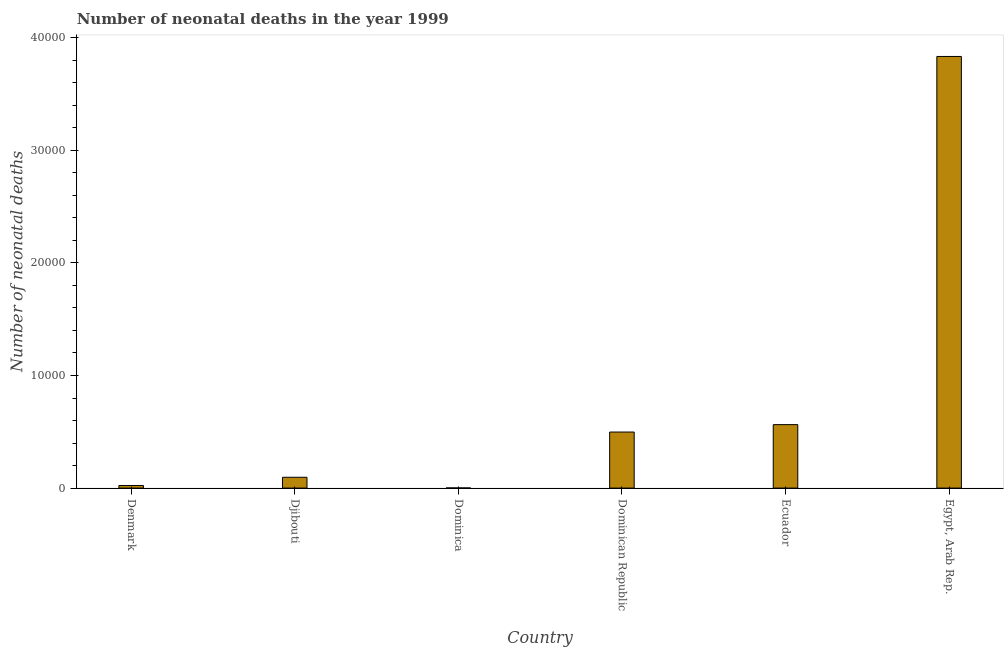Does the graph contain any zero values?
Your answer should be compact. No. What is the title of the graph?
Ensure brevity in your answer.  Number of neonatal deaths in the year 1999. What is the label or title of the Y-axis?
Offer a terse response. Number of neonatal deaths. What is the number of neonatal deaths in Ecuador?
Your response must be concise. 5636. Across all countries, what is the maximum number of neonatal deaths?
Offer a terse response. 3.83e+04. Across all countries, what is the minimum number of neonatal deaths?
Offer a very short reply. 13. In which country was the number of neonatal deaths maximum?
Keep it short and to the point. Egypt, Arab Rep. In which country was the number of neonatal deaths minimum?
Keep it short and to the point. Dominica. What is the sum of the number of neonatal deaths?
Provide a short and direct response. 5.02e+04. What is the difference between the number of neonatal deaths in Denmark and Dominica?
Give a very brief answer. 218. What is the average number of neonatal deaths per country?
Offer a very short reply. 8359. What is the median number of neonatal deaths?
Your answer should be very brief. 2969.5. In how many countries, is the number of neonatal deaths greater than 22000 ?
Your answer should be compact. 1. What is the ratio of the number of neonatal deaths in Dominica to that in Dominican Republic?
Ensure brevity in your answer.  0. Is the number of neonatal deaths in Dominican Republic less than that in Ecuador?
Offer a very short reply. Yes. What is the difference between the highest and the second highest number of neonatal deaths?
Make the answer very short. 3.27e+04. What is the difference between the highest and the lowest number of neonatal deaths?
Offer a terse response. 3.83e+04. How many bars are there?
Provide a succinct answer. 6. How many countries are there in the graph?
Offer a very short reply. 6. What is the difference between two consecutive major ticks on the Y-axis?
Offer a very short reply. 10000. What is the Number of neonatal deaths in Denmark?
Keep it short and to the point. 231. What is the Number of neonatal deaths of Djibouti?
Keep it short and to the point. 961. What is the Number of neonatal deaths of Dominican Republic?
Ensure brevity in your answer.  4978. What is the Number of neonatal deaths in Ecuador?
Your response must be concise. 5636. What is the Number of neonatal deaths in Egypt, Arab Rep.?
Your answer should be compact. 3.83e+04. What is the difference between the Number of neonatal deaths in Denmark and Djibouti?
Keep it short and to the point. -730. What is the difference between the Number of neonatal deaths in Denmark and Dominica?
Offer a very short reply. 218. What is the difference between the Number of neonatal deaths in Denmark and Dominican Republic?
Provide a succinct answer. -4747. What is the difference between the Number of neonatal deaths in Denmark and Ecuador?
Your answer should be very brief. -5405. What is the difference between the Number of neonatal deaths in Denmark and Egypt, Arab Rep.?
Your answer should be very brief. -3.81e+04. What is the difference between the Number of neonatal deaths in Djibouti and Dominica?
Your response must be concise. 948. What is the difference between the Number of neonatal deaths in Djibouti and Dominican Republic?
Give a very brief answer. -4017. What is the difference between the Number of neonatal deaths in Djibouti and Ecuador?
Your answer should be compact. -4675. What is the difference between the Number of neonatal deaths in Djibouti and Egypt, Arab Rep.?
Make the answer very short. -3.74e+04. What is the difference between the Number of neonatal deaths in Dominica and Dominican Republic?
Offer a very short reply. -4965. What is the difference between the Number of neonatal deaths in Dominica and Ecuador?
Offer a terse response. -5623. What is the difference between the Number of neonatal deaths in Dominica and Egypt, Arab Rep.?
Make the answer very short. -3.83e+04. What is the difference between the Number of neonatal deaths in Dominican Republic and Ecuador?
Give a very brief answer. -658. What is the difference between the Number of neonatal deaths in Dominican Republic and Egypt, Arab Rep.?
Make the answer very short. -3.34e+04. What is the difference between the Number of neonatal deaths in Ecuador and Egypt, Arab Rep.?
Offer a terse response. -3.27e+04. What is the ratio of the Number of neonatal deaths in Denmark to that in Djibouti?
Your answer should be compact. 0.24. What is the ratio of the Number of neonatal deaths in Denmark to that in Dominica?
Offer a terse response. 17.77. What is the ratio of the Number of neonatal deaths in Denmark to that in Dominican Republic?
Make the answer very short. 0.05. What is the ratio of the Number of neonatal deaths in Denmark to that in Ecuador?
Your response must be concise. 0.04. What is the ratio of the Number of neonatal deaths in Denmark to that in Egypt, Arab Rep.?
Make the answer very short. 0.01. What is the ratio of the Number of neonatal deaths in Djibouti to that in Dominica?
Your answer should be compact. 73.92. What is the ratio of the Number of neonatal deaths in Djibouti to that in Dominican Republic?
Your answer should be compact. 0.19. What is the ratio of the Number of neonatal deaths in Djibouti to that in Ecuador?
Offer a very short reply. 0.17. What is the ratio of the Number of neonatal deaths in Djibouti to that in Egypt, Arab Rep.?
Ensure brevity in your answer.  0.03. What is the ratio of the Number of neonatal deaths in Dominica to that in Dominican Republic?
Your response must be concise. 0. What is the ratio of the Number of neonatal deaths in Dominica to that in Ecuador?
Your answer should be very brief. 0. What is the ratio of the Number of neonatal deaths in Dominican Republic to that in Ecuador?
Make the answer very short. 0.88. What is the ratio of the Number of neonatal deaths in Dominican Republic to that in Egypt, Arab Rep.?
Provide a short and direct response. 0.13. What is the ratio of the Number of neonatal deaths in Ecuador to that in Egypt, Arab Rep.?
Make the answer very short. 0.15. 